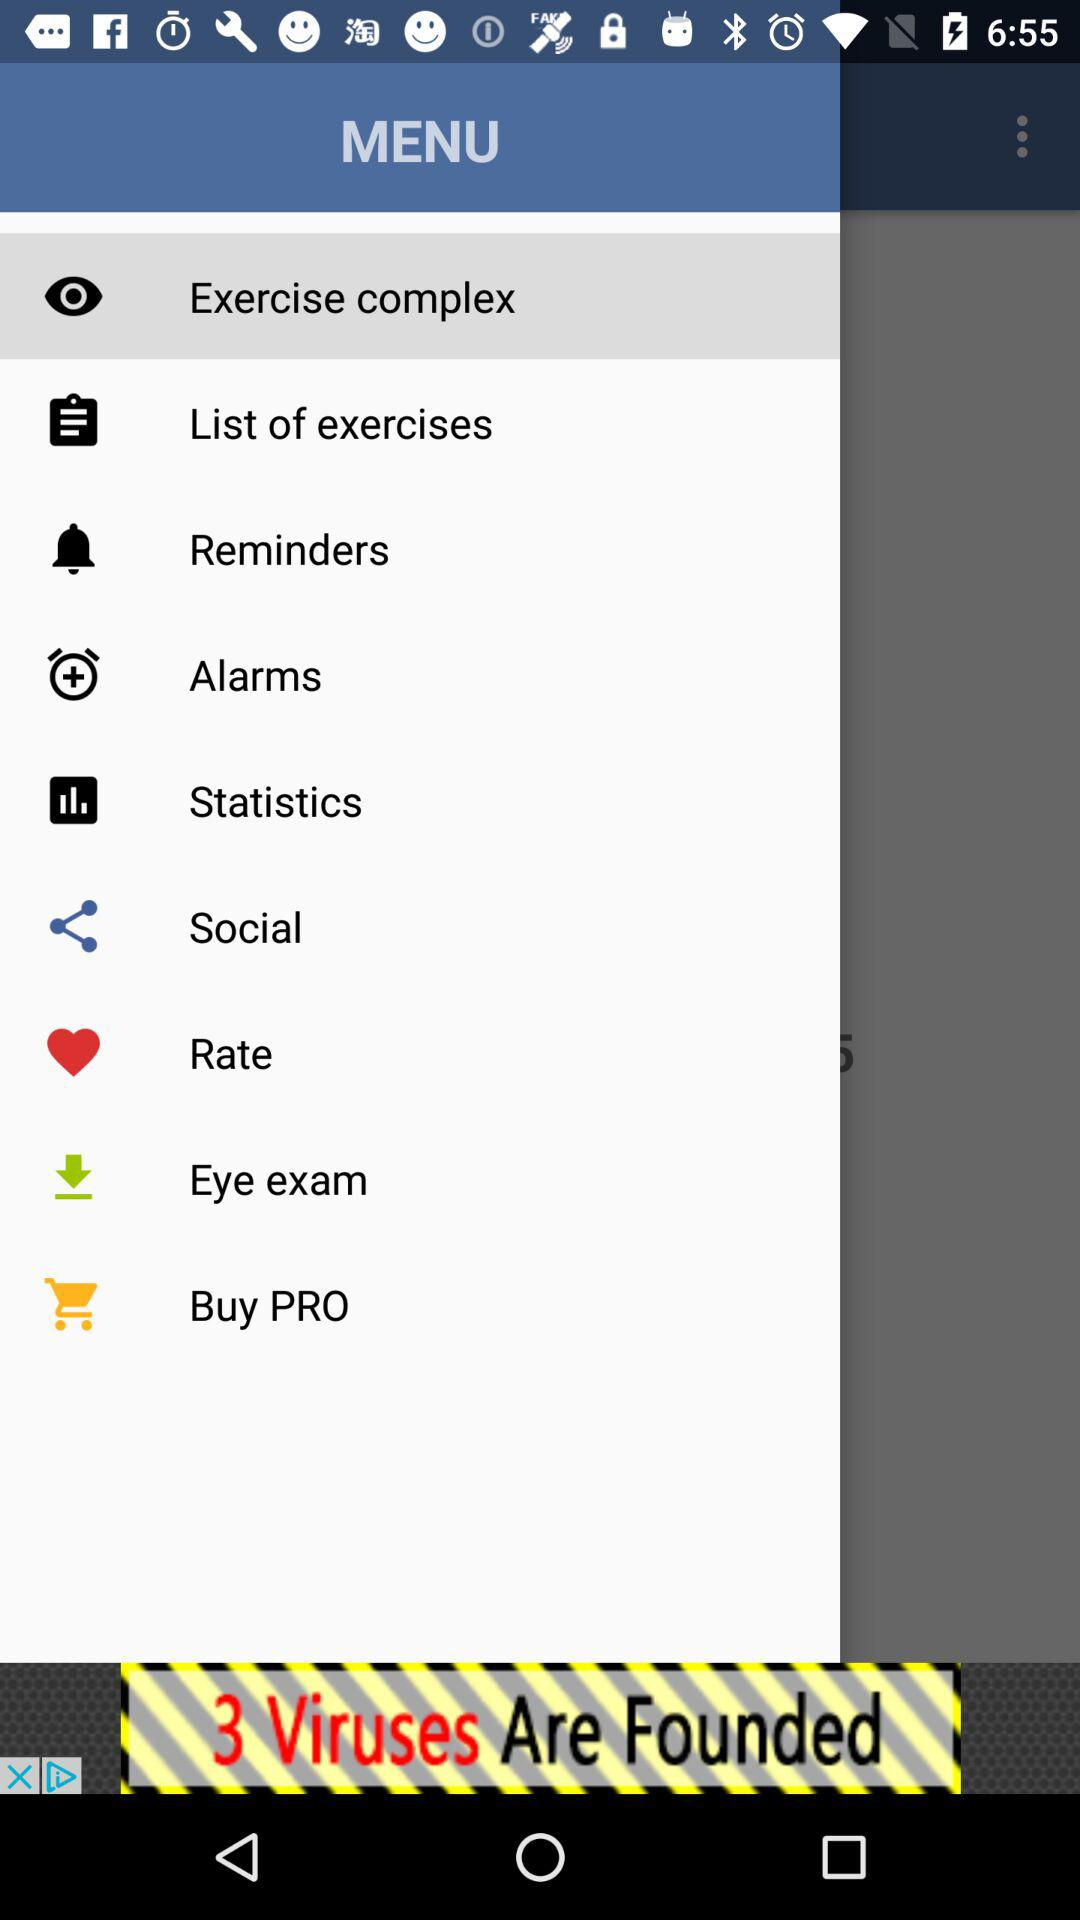What's the selected menu option? The selected menu option is "Exercise complex". 